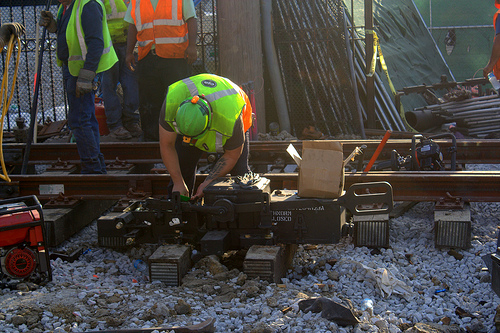<image>
Can you confirm if the man is to the left of the man? Yes. From this viewpoint, the man is positioned to the left side relative to the man. 